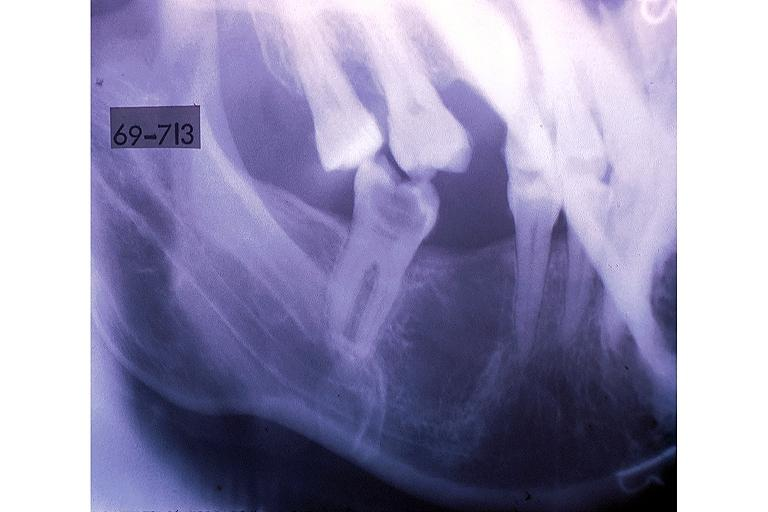does medulloblastoma show hematopoietic bone marrow defect?
Answer the question using a single word or phrase. No 